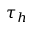Convert formula to latex. <formula><loc_0><loc_0><loc_500><loc_500>\tau _ { h }</formula> 